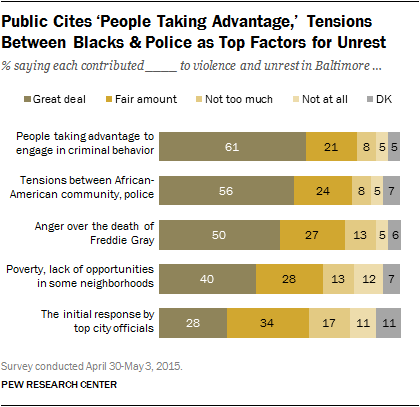List a handful of essential elements in this visual. Out of the tensions that have over 50, a great deal of them are located in the range of 2. The chart includes a total of 5 tensions. 